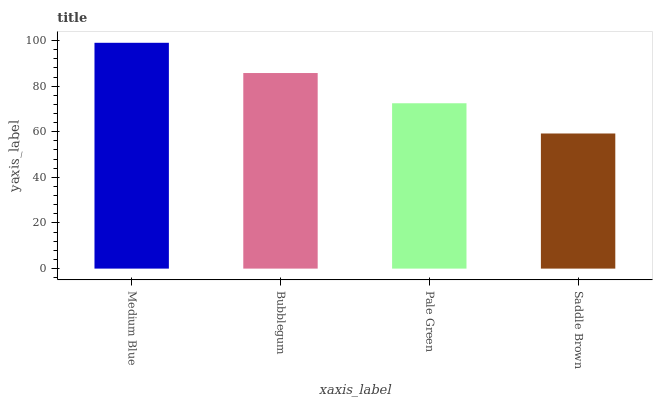Is Saddle Brown the minimum?
Answer yes or no. Yes. Is Medium Blue the maximum?
Answer yes or no. Yes. Is Bubblegum the minimum?
Answer yes or no. No. Is Bubblegum the maximum?
Answer yes or no. No. Is Medium Blue greater than Bubblegum?
Answer yes or no. Yes. Is Bubblegum less than Medium Blue?
Answer yes or no. Yes. Is Bubblegum greater than Medium Blue?
Answer yes or no. No. Is Medium Blue less than Bubblegum?
Answer yes or no. No. Is Bubblegum the high median?
Answer yes or no. Yes. Is Pale Green the low median?
Answer yes or no. Yes. Is Pale Green the high median?
Answer yes or no. No. Is Saddle Brown the low median?
Answer yes or no. No. 